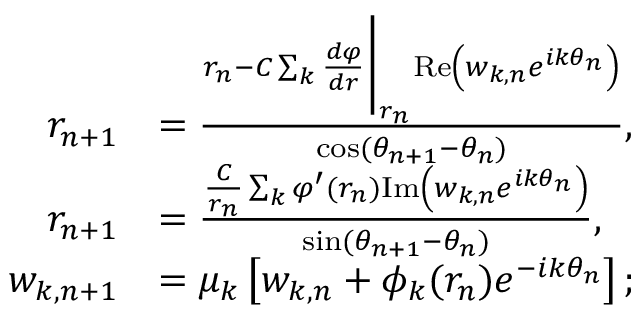Convert formula to latex. <formula><loc_0><loc_0><loc_500><loc_500>\begin{array} { r l } { r _ { n + 1 } } & { = \frac { r _ { n } - C \sum _ { k } \frac { d \varphi } { d r } \Big | _ { r _ { n } } R e \left ( w _ { k , n } e ^ { i k \theta _ { n } } \right ) } { \cos ( \theta _ { n + 1 } - \theta _ { n } ) } , } \\ { r _ { n + 1 } } & { = \frac { \frac { C } { r _ { n } } \sum _ { k } \varphi ^ { \prime } ( r _ { n } ) I m \left ( w _ { k , n } e ^ { i k \theta _ { n } } \right ) } { \sin ( \theta _ { n + 1 } - \theta _ { n } ) } , } \\ { w _ { k , n + 1 } } & { = \mu _ { k } \left [ w _ { k , n } + \phi _ { k } ( r _ { n } ) e ^ { - i k \theta _ { n } } \right ] ; } \end{array}</formula> 